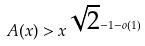Convert formula to latex. <formula><loc_0><loc_0><loc_500><loc_500>A ( x ) > x ^ { \sqrt { 2 } - 1 - o ( 1 ) }</formula> 